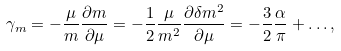<formula> <loc_0><loc_0><loc_500><loc_500>\gamma _ { m } = - \frac { \mu } { m } \frac { \partial m } { \partial \mu } = - \frac { 1 } { 2 } \frac { \mu } { m ^ { 2 } } \frac { \partial \delta m ^ { 2 } } { \partial \mu } = - \frac { 3 } { 2 } \frac { \alpha } { \pi } + \dots ,</formula> 